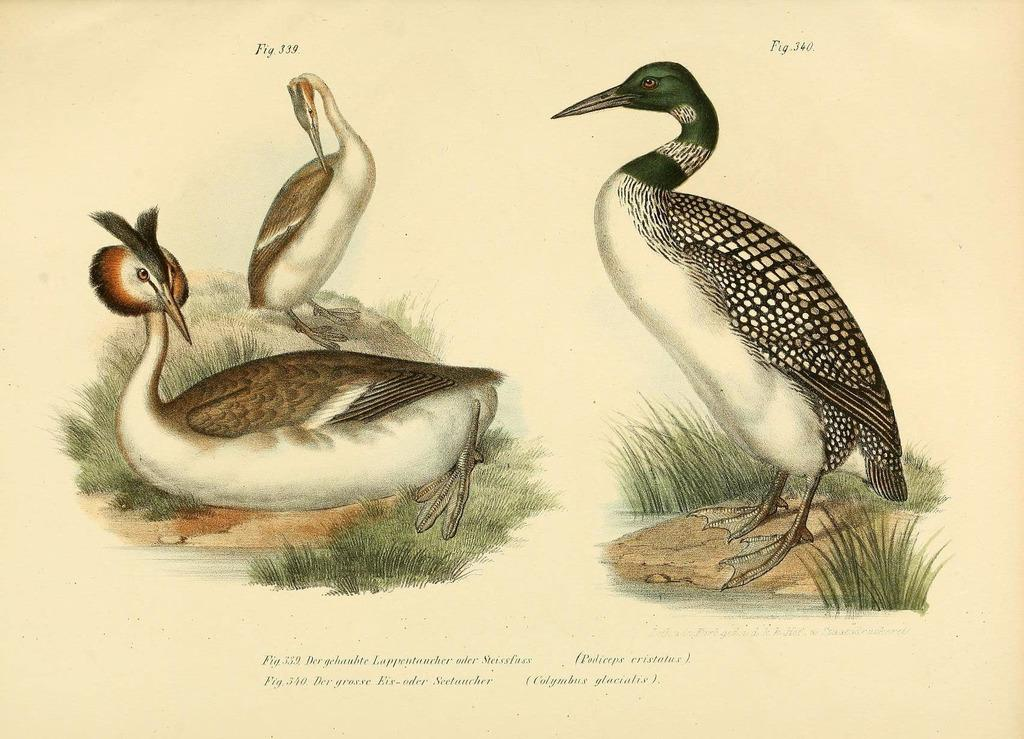What is featured on the poster in the image? The poster contains a painting of birds and grass. What else can be found on the poster besides the painting? There is text on the poster. What is visible below the poster in the image? There is ground visible in the image. How does the poster provide comfort to the birds in the image? The poster does not provide comfort to the birds, as it is a two-dimensional representation of birds and grass. What type of power source is used to keep the lizards visible in the image? There are no lizards present in the image, so there is no power source needed to keep them visible. 